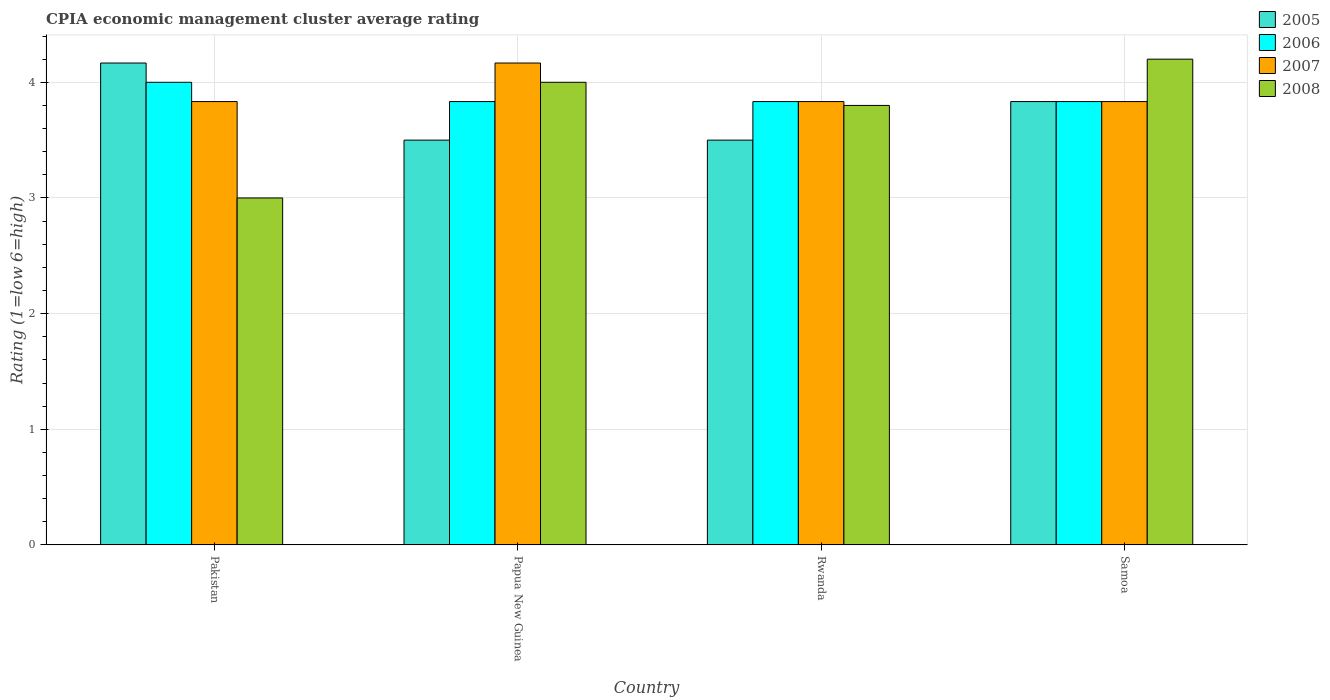How many different coloured bars are there?
Offer a very short reply. 4. How many groups of bars are there?
Provide a succinct answer. 4. Are the number of bars per tick equal to the number of legend labels?
Keep it short and to the point. Yes. Are the number of bars on each tick of the X-axis equal?
Your answer should be very brief. Yes. How many bars are there on the 3rd tick from the right?
Make the answer very short. 4. What is the CPIA rating in 2007 in Papua New Guinea?
Your response must be concise. 4.17. Across all countries, what is the maximum CPIA rating in 2005?
Your answer should be very brief. 4.17. In which country was the CPIA rating in 2007 maximum?
Offer a very short reply. Papua New Guinea. What is the total CPIA rating in 2006 in the graph?
Make the answer very short. 15.5. What is the difference between the CPIA rating in 2007 in Pakistan and that in Rwanda?
Offer a very short reply. 0. What is the difference between the CPIA rating in 2005 in Pakistan and the CPIA rating in 2008 in Rwanda?
Provide a succinct answer. 0.37. What is the average CPIA rating in 2008 per country?
Your response must be concise. 3.75. What is the difference between the CPIA rating of/in 2005 and CPIA rating of/in 2008 in Samoa?
Offer a very short reply. -0.37. In how many countries, is the CPIA rating in 2008 greater than 1.6?
Your answer should be compact. 4. What is the ratio of the CPIA rating in 2007 in Rwanda to that in Samoa?
Offer a very short reply. 1. What is the difference between the highest and the second highest CPIA rating in 2008?
Your answer should be compact. -0.4. What is the difference between the highest and the lowest CPIA rating in 2007?
Provide a short and direct response. 0.33. Is the sum of the CPIA rating in 2005 in Papua New Guinea and Samoa greater than the maximum CPIA rating in 2007 across all countries?
Offer a very short reply. Yes. Is it the case that in every country, the sum of the CPIA rating in 2008 and CPIA rating in 2007 is greater than the sum of CPIA rating in 2006 and CPIA rating in 2005?
Give a very brief answer. No. What does the 4th bar from the left in Pakistan represents?
Your answer should be very brief. 2008. What does the 4th bar from the right in Rwanda represents?
Offer a terse response. 2005. Are all the bars in the graph horizontal?
Your answer should be very brief. No. Does the graph contain any zero values?
Your answer should be compact. No. Does the graph contain grids?
Your answer should be very brief. Yes. How are the legend labels stacked?
Provide a succinct answer. Vertical. What is the title of the graph?
Offer a very short reply. CPIA economic management cluster average rating. What is the label or title of the X-axis?
Provide a succinct answer. Country. What is the Rating (1=low 6=high) in 2005 in Pakistan?
Ensure brevity in your answer.  4.17. What is the Rating (1=low 6=high) in 2006 in Pakistan?
Your answer should be very brief. 4. What is the Rating (1=low 6=high) of 2007 in Pakistan?
Offer a terse response. 3.83. What is the Rating (1=low 6=high) in 2005 in Papua New Guinea?
Keep it short and to the point. 3.5. What is the Rating (1=low 6=high) of 2006 in Papua New Guinea?
Your answer should be very brief. 3.83. What is the Rating (1=low 6=high) in 2007 in Papua New Guinea?
Make the answer very short. 4.17. What is the Rating (1=low 6=high) of 2008 in Papua New Guinea?
Your answer should be very brief. 4. What is the Rating (1=low 6=high) of 2006 in Rwanda?
Offer a very short reply. 3.83. What is the Rating (1=low 6=high) of 2007 in Rwanda?
Provide a succinct answer. 3.83. What is the Rating (1=low 6=high) of 2005 in Samoa?
Provide a succinct answer. 3.83. What is the Rating (1=low 6=high) of 2006 in Samoa?
Your answer should be very brief. 3.83. What is the Rating (1=low 6=high) in 2007 in Samoa?
Your answer should be very brief. 3.83. What is the Rating (1=low 6=high) of 2008 in Samoa?
Make the answer very short. 4.2. Across all countries, what is the maximum Rating (1=low 6=high) of 2005?
Provide a short and direct response. 4.17. Across all countries, what is the maximum Rating (1=low 6=high) of 2007?
Offer a very short reply. 4.17. Across all countries, what is the maximum Rating (1=low 6=high) in 2008?
Ensure brevity in your answer.  4.2. Across all countries, what is the minimum Rating (1=low 6=high) in 2005?
Provide a succinct answer. 3.5. Across all countries, what is the minimum Rating (1=low 6=high) in 2006?
Give a very brief answer. 3.83. Across all countries, what is the minimum Rating (1=low 6=high) of 2007?
Your answer should be very brief. 3.83. Across all countries, what is the minimum Rating (1=low 6=high) of 2008?
Provide a short and direct response. 3. What is the total Rating (1=low 6=high) of 2005 in the graph?
Keep it short and to the point. 15. What is the total Rating (1=low 6=high) of 2006 in the graph?
Your response must be concise. 15.5. What is the total Rating (1=low 6=high) in 2007 in the graph?
Make the answer very short. 15.67. What is the difference between the Rating (1=low 6=high) of 2005 in Pakistan and that in Papua New Guinea?
Provide a short and direct response. 0.67. What is the difference between the Rating (1=low 6=high) of 2005 in Pakistan and that in Rwanda?
Make the answer very short. 0.67. What is the difference between the Rating (1=low 6=high) of 2007 in Pakistan and that in Rwanda?
Your answer should be very brief. 0. What is the difference between the Rating (1=low 6=high) in 2005 in Pakistan and that in Samoa?
Your answer should be very brief. 0.33. What is the difference between the Rating (1=low 6=high) in 2007 in Pakistan and that in Samoa?
Keep it short and to the point. 0. What is the difference between the Rating (1=low 6=high) in 2005 in Papua New Guinea and that in Rwanda?
Provide a succinct answer. 0. What is the difference between the Rating (1=low 6=high) of 2008 in Papua New Guinea and that in Rwanda?
Offer a terse response. 0.2. What is the difference between the Rating (1=low 6=high) in 2005 in Papua New Guinea and that in Samoa?
Ensure brevity in your answer.  -0.33. What is the difference between the Rating (1=low 6=high) in 2007 in Papua New Guinea and that in Samoa?
Your answer should be very brief. 0.33. What is the difference between the Rating (1=low 6=high) of 2008 in Papua New Guinea and that in Samoa?
Ensure brevity in your answer.  -0.2. What is the difference between the Rating (1=low 6=high) in 2005 in Rwanda and that in Samoa?
Your response must be concise. -0.33. What is the difference between the Rating (1=low 6=high) in 2005 in Pakistan and the Rating (1=low 6=high) in 2007 in Papua New Guinea?
Ensure brevity in your answer.  0. What is the difference between the Rating (1=low 6=high) of 2006 in Pakistan and the Rating (1=low 6=high) of 2008 in Papua New Guinea?
Make the answer very short. 0. What is the difference between the Rating (1=low 6=high) of 2007 in Pakistan and the Rating (1=low 6=high) of 2008 in Papua New Guinea?
Keep it short and to the point. -0.17. What is the difference between the Rating (1=low 6=high) in 2005 in Pakistan and the Rating (1=low 6=high) in 2006 in Rwanda?
Ensure brevity in your answer.  0.33. What is the difference between the Rating (1=low 6=high) of 2005 in Pakistan and the Rating (1=low 6=high) of 2007 in Rwanda?
Keep it short and to the point. 0.33. What is the difference between the Rating (1=low 6=high) in 2005 in Pakistan and the Rating (1=low 6=high) in 2008 in Rwanda?
Offer a terse response. 0.37. What is the difference between the Rating (1=low 6=high) of 2005 in Pakistan and the Rating (1=low 6=high) of 2007 in Samoa?
Give a very brief answer. 0.33. What is the difference between the Rating (1=low 6=high) of 2005 in Pakistan and the Rating (1=low 6=high) of 2008 in Samoa?
Make the answer very short. -0.03. What is the difference between the Rating (1=low 6=high) in 2006 in Pakistan and the Rating (1=low 6=high) in 2007 in Samoa?
Your response must be concise. 0.17. What is the difference between the Rating (1=low 6=high) in 2007 in Pakistan and the Rating (1=low 6=high) in 2008 in Samoa?
Provide a short and direct response. -0.37. What is the difference between the Rating (1=low 6=high) in 2005 in Papua New Guinea and the Rating (1=low 6=high) in 2006 in Rwanda?
Offer a very short reply. -0.33. What is the difference between the Rating (1=low 6=high) of 2007 in Papua New Guinea and the Rating (1=low 6=high) of 2008 in Rwanda?
Ensure brevity in your answer.  0.37. What is the difference between the Rating (1=low 6=high) in 2005 in Papua New Guinea and the Rating (1=low 6=high) in 2006 in Samoa?
Provide a short and direct response. -0.33. What is the difference between the Rating (1=low 6=high) in 2005 in Papua New Guinea and the Rating (1=low 6=high) in 2007 in Samoa?
Your response must be concise. -0.33. What is the difference between the Rating (1=low 6=high) of 2005 in Papua New Guinea and the Rating (1=low 6=high) of 2008 in Samoa?
Provide a short and direct response. -0.7. What is the difference between the Rating (1=low 6=high) of 2006 in Papua New Guinea and the Rating (1=low 6=high) of 2008 in Samoa?
Provide a short and direct response. -0.37. What is the difference between the Rating (1=low 6=high) of 2007 in Papua New Guinea and the Rating (1=low 6=high) of 2008 in Samoa?
Give a very brief answer. -0.03. What is the difference between the Rating (1=low 6=high) in 2005 in Rwanda and the Rating (1=low 6=high) in 2006 in Samoa?
Your answer should be very brief. -0.33. What is the difference between the Rating (1=low 6=high) in 2005 in Rwanda and the Rating (1=low 6=high) in 2008 in Samoa?
Give a very brief answer. -0.7. What is the difference between the Rating (1=low 6=high) of 2006 in Rwanda and the Rating (1=low 6=high) of 2008 in Samoa?
Offer a terse response. -0.37. What is the difference between the Rating (1=low 6=high) of 2007 in Rwanda and the Rating (1=low 6=high) of 2008 in Samoa?
Provide a short and direct response. -0.37. What is the average Rating (1=low 6=high) of 2005 per country?
Give a very brief answer. 3.75. What is the average Rating (1=low 6=high) of 2006 per country?
Your answer should be compact. 3.88. What is the average Rating (1=low 6=high) in 2007 per country?
Offer a very short reply. 3.92. What is the average Rating (1=low 6=high) in 2008 per country?
Your answer should be very brief. 3.75. What is the difference between the Rating (1=low 6=high) of 2005 and Rating (1=low 6=high) of 2006 in Pakistan?
Offer a terse response. 0.17. What is the difference between the Rating (1=low 6=high) of 2005 and Rating (1=low 6=high) of 2008 in Pakistan?
Ensure brevity in your answer.  1.17. What is the difference between the Rating (1=low 6=high) in 2006 and Rating (1=low 6=high) in 2007 in Pakistan?
Make the answer very short. 0.17. What is the difference between the Rating (1=low 6=high) in 2006 and Rating (1=low 6=high) in 2008 in Pakistan?
Ensure brevity in your answer.  1. What is the difference between the Rating (1=low 6=high) of 2007 and Rating (1=low 6=high) of 2008 in Pakistan?
Your response must be concise. 0.83. What is the difference between the Rating (1=low 6=high) in 2005 and Rating (1=low 6=high) in 2008 in Papua New Guinea?
Your answer should be very brief. -0.5. What is the difference between the Rating (1=low 6=high) in 2006 and Rating (1=low 6=high) in 2007 in Papua New Guinea?
Provide a short and direct response. -0.33. What is the difference between the Rating (1=low 6=high) in 2005 and Rating (1=low 6=high) in 2006 in Rwanda?
Your response must be concise. -0.33. What is the difference between the Rating (1=low 6=high) in 2005 and Rating (1=low 6=high) in 2008 in Rwanda?
Provide a succinct answer. -0.3. What is the difference between the Rating (1=low 6=high) of 2006 and Rating (1=low 6=high) of 2008 in Rwanda?
Offer a very short reply. 0.03. What is the difference between the Rating (1=low 6=high) of 2007 and Rating (1=low 6=high) of 2008 in Rwanda?
Keep it short and to the point. 0.03. What is the difference between the Rating (1=low 6=high) of 2005 and Rating (1=low 6=high) of 2007 in Samoa?
Your answer should be very brief. 0. What is the difference between the Rating (1=low 6=high) in 2005 and Rating (1=low 6=high) in 2008 in Samoa?
Give a very brief answer. -0.37. What is the difference between the Rating (1=low 6=high) in 2006 and Rating (1=low 6=high) in 2008 in Samoa?
Give a very brief answer. -0.37. What is the difference between the Rating (1=low 6=high) of 2007 and Rating (1=low 6=high) of 2008 in Samoa?
Offer a terse response. -0.37. What is the ratio of the Rating (1=low 6=high) of 2005 in Pakistan to that in Papua New Guinea?
Provide a succinct answer. 1.19. What is the ratio of the Rating (1=low 6=high) in 2006 in Pakistan to that in Papua New Guinea?
Ensure brevity in your answer.  1.04. What is the ratio of the Rating (1=low 6=high) in 2007 in Pakistan to that in Papua New Guinea?
Your answer should be very brief. 0.92. What is the ratio of the Rating (1=low 6=high) in 2005 in Pakistan to that in Rwanda?
Keep it short and to the point. 1.19. What is the ratio of the Rating (1=low 6=high) of 2006 in Pakistan to that in Rwanda?
Your answer should be compact. 1.04. What is the ratio of the Rating (1=low 6=high) of 2007 in Pakistan to that in Rwanda?
Keep it short and to the point. 1. What is the ratio of the Rating (1=low 6=high) of 2008 in Pakistan to that in Rwanda?
Give a very brief answer. 0.79. What is the ratio of the Rating (1=low 6=high) of 2005 in Pakistan to that in Samoa?
Your answer should be compact. 1.09. What is the ratio of the Rating (1=low 6=high) in 2006 in Pakistan to that in Samoa?
Your answer should be compact. 1.04. What is the ratio of the Rating (1=low 6=high) of 2007 in Pakistan to that in Samoa?
Your response must be concise. 1. What is the ratio of the Rating (1=low 6=high) of 2005 in Papua New Guinea to that in Rwanda?
Make the answer very short. 1. What is the ratio of the Rating (1=low 6=high) in 2006 in Papua New Guinea to that in Rwanda?
Your response must be concise. 1. What is the ratio of the Rating (1=low 6=high) of 2007 in Papua New Guinea to that in Rwanda?
Make the answer very short. 1.09. What is the ratio of the Rating (1=low 6=high) of 2008 in Papua New Guinea to that in Rwanda?
Offer a very short reply. 1.05. What is the ratio of the Rating (1=low 6=high) of 2007 in Papua New Guinea to that in Samoa?
Provide a short and direct response. 1.09. What is the ratio of the Rating (1=low 6=high) of 2008 in Papua New Guinea to that in Samoa?
Provide a succinct answer. 0.95. What is the ratio of the Rating (1=low 6=high) of 2007 in Rwanda to that in Samoa?
Keep it short and to the point. 1. What is the ratio of the Rating (1=low 6=high) in 2008 in Rwanda to that in Samoa?
Provide a short and direct response. 0.9. What is the difference between the highest and the second highest Rating (1=low 6=high) in 2006?
Offer a terse response. 0.17. What is the difference between the highest and the second highest Rating (1=low 6=high) in 2008?
Provide a short and direct response. 0.2. What is the difference between the highest and the lowest Rating (1=low 6=high) of 2007?
Offer a very short reply. 0.33. What is the difference between the highest and the lowest Rating (1=low 6=high) of 2008?
Your answer should be compact. 1.2. 